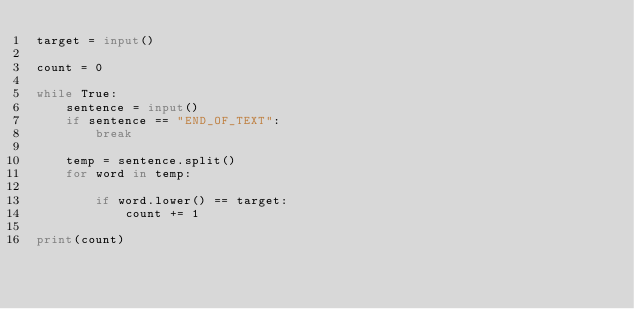Convert code to text. <code><loc_0><loc_0><loc_500><loc_500><_Python_>target = input()

count = 0

while True:
    sentence = input()
    if sentence == "END_OF_TEXT":
        break
        
    temp = sentence.split()
    for word in temp:
        
        if word.lower() == target:
            count += 1

print(count)
</code> 